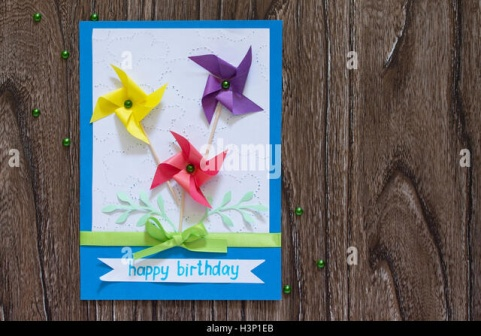Let's get really creative, imagine this card is a portal to a magical world. What kind of adventure awaits the recipient? Welcome to the realm beyond the birthday card! As you open the card, you’re whisked away through a swirl of vibrant colors into a magical land where the pinwheels transform into flourishing windmills atop floating islands. Each windmill generates a melody that harmonizes with the whimsical chime of enchanted flowers. Your journey begins with meeting the Cardian Pixies, guardians of this realm, who explain that the leaves and foliage on the card map out uncharted paths to secret gardens and crystalline lakes. Riding a giant, friendly bumblebee, you soar over emerald fields and sparkling streams, collecting tokens of joy to unlock the secrets of the Bejeweled Forest, where the green beads originate. In this forest, each bead tells a story and grants a wish to its holder. The adventure culminates at the Castle of Birthdays, a magnificent structure where every room celebrates a unique birthday tradition from different cultures. To return, you must plant a newly acquired magical seed in the realm, ensuring its continual bloom of happiness and then step through a glowing portal that brings you back with a heart full of joy and pockets filled with enchanted tokens. 